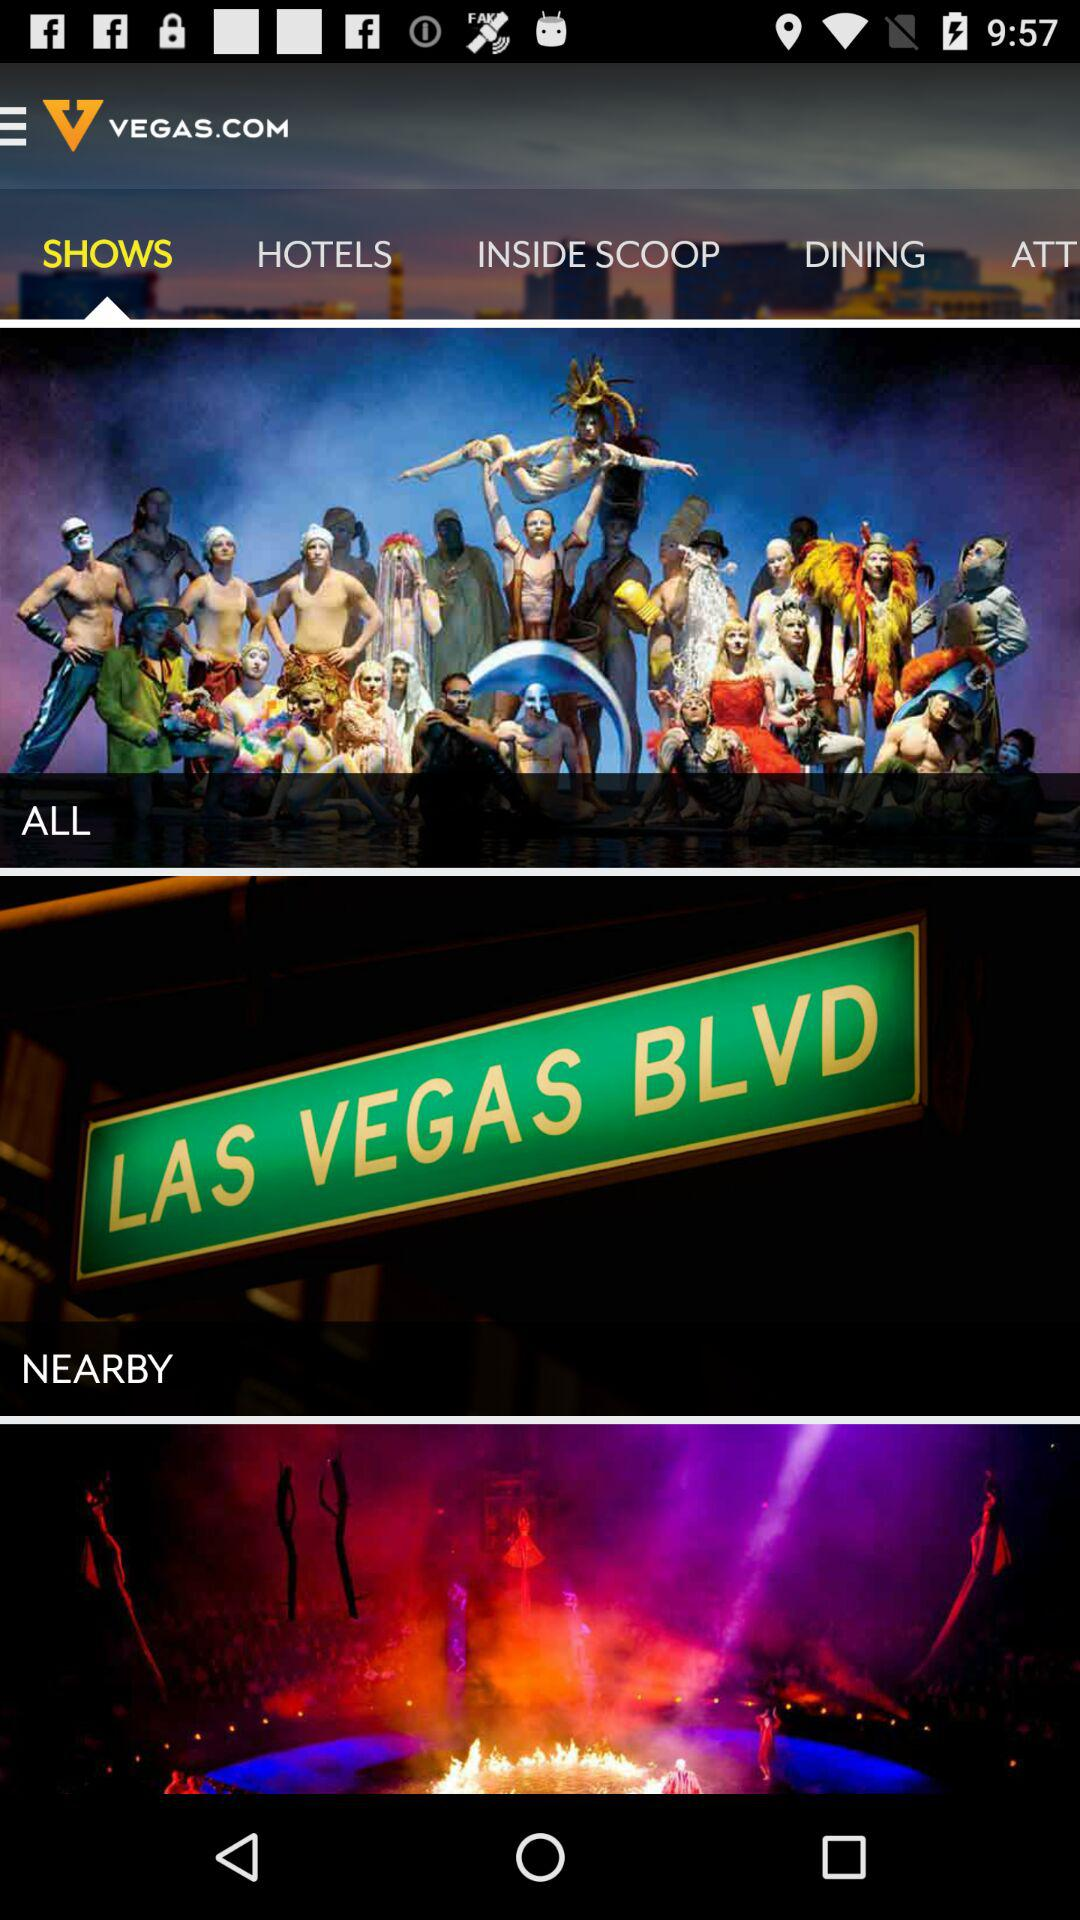What is the selected option? The selected option is "SHOWS". 